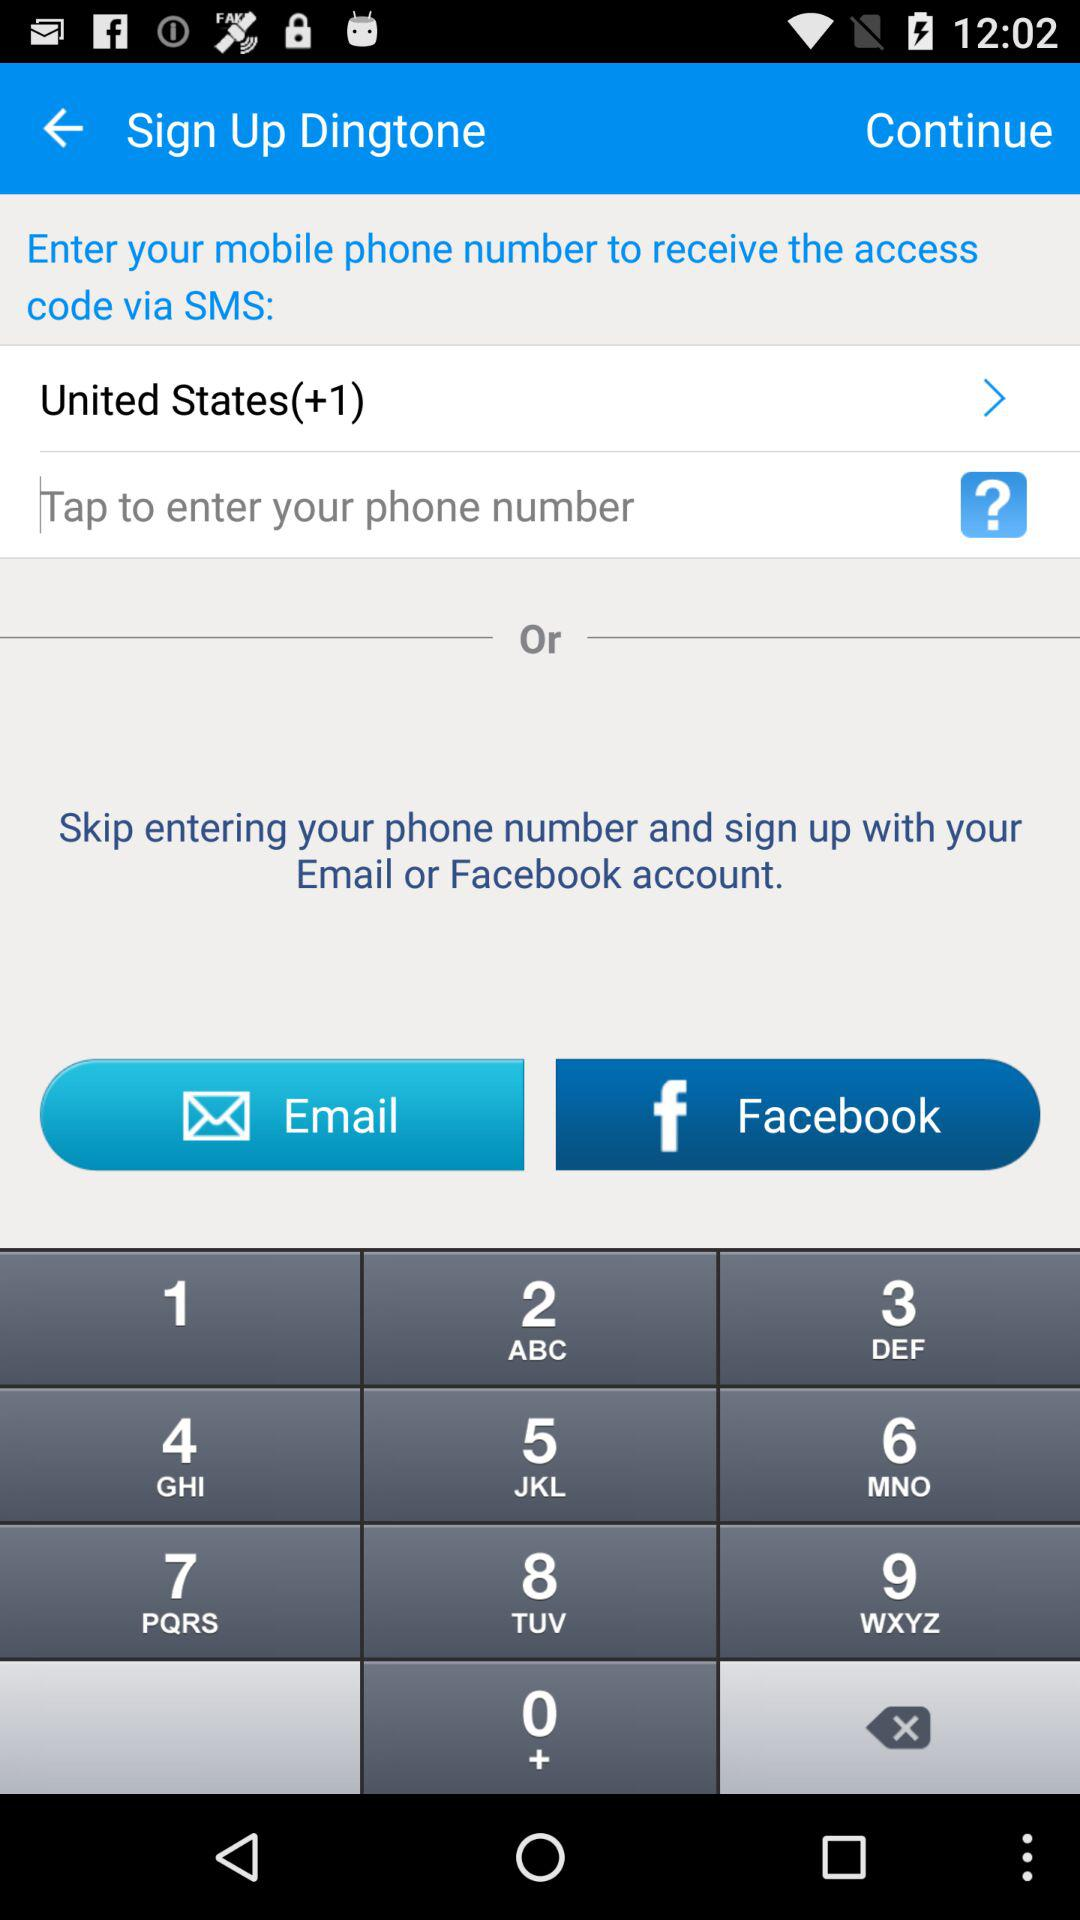What is the country code of the United States? The country code of the United States is +1. 